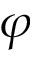Convert formula to latex. <formula><loc_0><loc_0><loc_500><loc_500>\varphi</formula> 